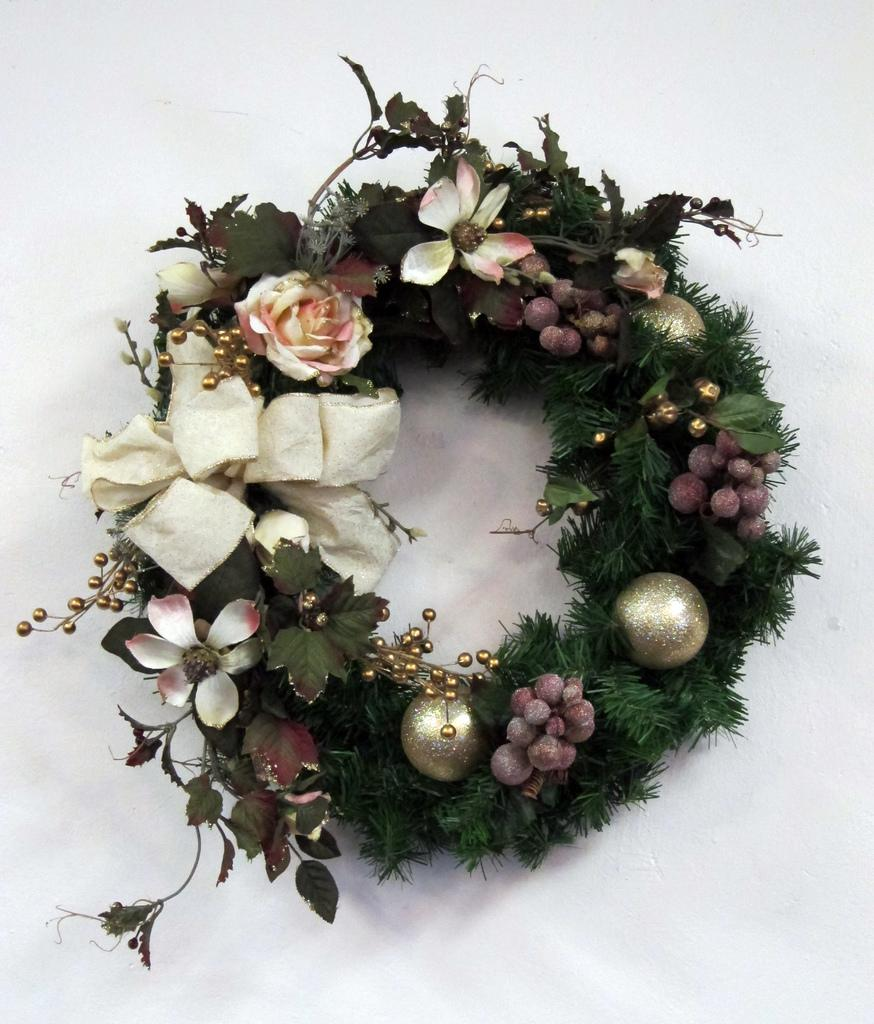What is the main object in the image? There is a wreath in the image. Where is the wreath located? The wreath is on an object. What type of cactus can be seen growing in the wreath in the image? There is no cactus present in the image; it only features a wreath on an object. 